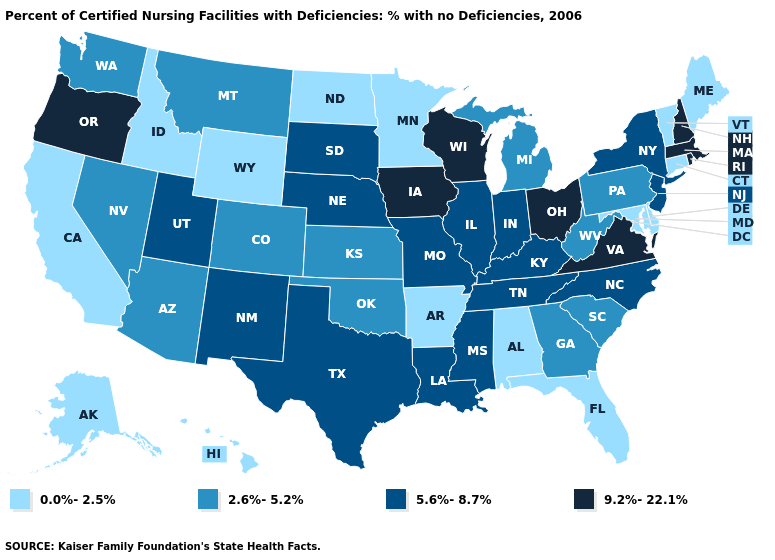Among the states that border South Carolina , which have the lowest value?
Answer briefly. Georgia. What is the value of New Mexico?
Short answer required. 5.6%-8.7%. Name the states that have a value in the range 2.6%-5.2%?
Short answer required. Arizona, Colorado, Georgia, Kansas, Michigan, Montana, Nevada, Oklahoma, Pennsylvania, South Carolina, Washington, West Virginia. Name the states that have a value in the range 5.6%-8.7%?
Be succinct. Illinois, Indiana, Kentucky, Louisiana, Mississippi, Missouri, Nebraska, New Jersey, New Mexico, New York, North Carolina, South Dakota, Tennessee, Texas, Utah. What is the highest value in the South ?
Keep it brief. 9.2%-22.1%. Which states have the lowest value in the MidWest?
Be succinct. Minnesota, North Dakota. Does Delaware have a higher value than West Virginia?
Write a very short answer. No. Which states hav the highest value in the West?
Be succinct. Oregon. What is the value of New Mexico?
Keep it brief. 5.6%-8.7%. What is the value of Rhode Island?
Concise answer only. 9.2%-22.1%. Which states have the highest value in the USA?
Write a very short answer. Iowa, Massachusetts, New Hampshire, Ohio, Oregon, Rhode Island, Virginia, Wisconsin. Name the states that have a value in the range 5.6%-8.7%?
Concise answer only. Illinois, Indiana, Kentucky, Louisiana, Mississippi, Missouri, Nebraska, New Jersey, New Mexico, New York, North Carolina, South Dakota, Tennessee, Texas, Utah. Among the states that border South Carolina , which have the lowest value?
Write a very short answer. Georgia. Name the states that have a value in the range 2.6%-5.2%?
Answer briefly. Arizona, Colorado, Georgia, Kansas, Michigan, Montana, Nevada, Oklahoma, Pennsylvania, South Carolina, Washington, West Virginia. Name the states that have a value in the range 2.6%-5.2%?
Answer briefly. Arizona, Colorado, Georgia, Kansas, Michigan, Montana, Nevada, Oklahoma, Pennsylvania, South Carolina, Washington, West Virginia. 